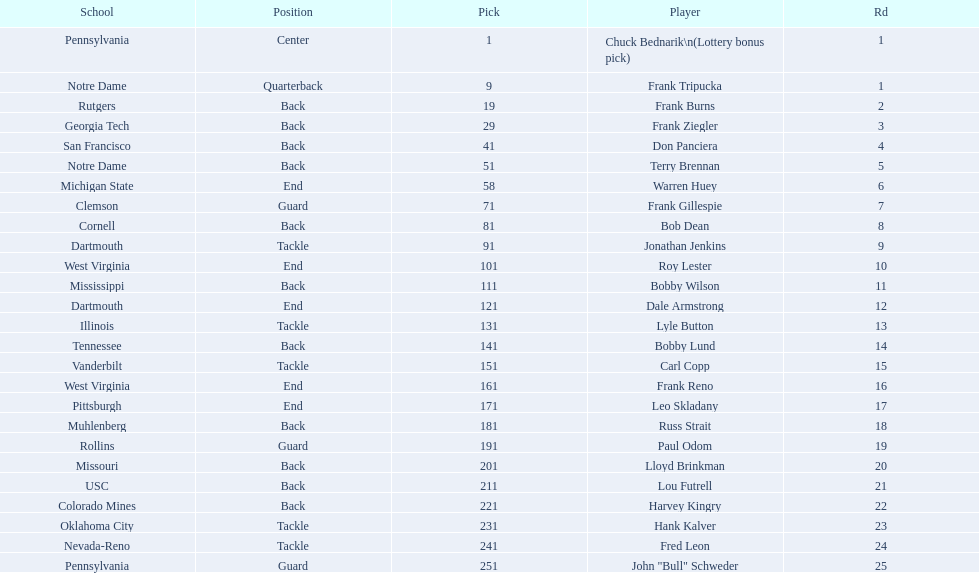Highest rd number? 25. Would you mind parsing the complete table? {'header': ['School', 'Position', 'Pick', 'Player', 'Rd'], 'rows': [['Pennsylvania', 'Center', '1', 'Chuck Bednarik\\n(Lottery bonus pick)', '1'], ['Notre Dame', 'Quarterback', '9', 'Frank Tripucka', '1'], ['Rutgers', 'Back', '19', 'Frank Burns', '2'], ['Georgia Tech', 'Back', '29', 'Frank Ziegler', '3'], ['San Francisco', 'Back', '41', 'Don Panciera', '4'], ['Notre Dame', 'Back', '51', 'Terry Brennan', '5'], ['Michigan State', 'End', '58', 'Warren Huey', '6'], ['Clemson', 'Guard', '71', 'Frank Gillespie', '7'], ['Cornell', 'Back', '81', 'Bob Dean', '8'], ['Dartmouth', 'Tackle', '91', 'Jonathan Jenkins', '9'], ['West Virginia', 'End', '101', 'Roy Lester', '10'], ['Mississippi', 'Back', '111', 'Bobby Wilson', '11'], ['Dartmouth', 'End', '121', 'Dale Armstrong', '12'], ['Illinois', 'Tackle', '131', 'Lyle Button', '13'], ['Tennessee', 'Back', '141', 'Bobby Lund', '14'], ['Vanderbilt', 'Tackle', '151', 'Carl Copp', '15'], ['West Virginia', 'End', '161', 'Frank Reno', '16'], ['Pittsburgh', 'End', '171', 'Leo Skladany', '17'], ['Muhlenberg', 'Back', '181', 'Russ Strait', '18'], ['Rollins', 'Guard', '191', 'Paul Odom', '19'], ['Missouri', 'Back', '201', 'Lloyd Brinkman', '20'], ['USC', 'Back', '211', 'Lou Futrell', '21'], ['Colorado Mines', 'Back', '221', 'Harvey Kingry', '22'], ['Oklahoma City', 'Tackle', '231', 'Hank Kalver', '23'], ['Nevada-Reno', 'Tackle', '241', 'Fred Leon', '24'], ['Pennsylvania', 'Guard', '251', 'John "Bull" Schweder', '25']]} 